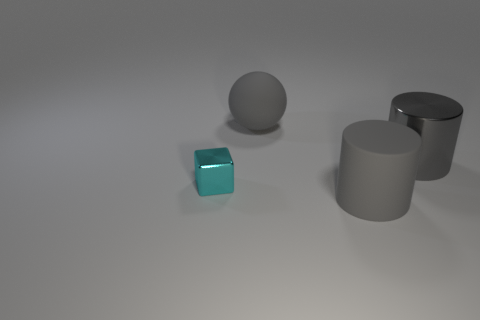Subtract all red cylinders. Subtract all green spheres. How many cylinders are left? 2 Add 4 large things. How many objects exist? 8 Subtract all balls. How many objects are left? 3 Add 1 gray rubber balls. How many gray rubber balls exist? 2 Subtract 0 purple balls. How many objects are left? 4 Subtract all purple cylinders. Subtract all large matte things. How many objects are left? 2 Add 4 balls. How many balls are left? 5 